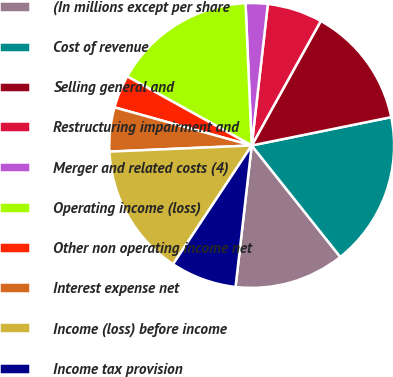Convert chart to OTSL. <chart><loc_0><loc_0><loc_500><loc_500><pie_chart><fcel>(In millions except per share<fcel>Cost of revenue<fcel>Selling general and<fcel>Restructuring impairment and<fcel>Merger and related costs (4)<fcel>Operating income (loss)<fcel>Other non operating income net<fcel>Interest expense net<fcel>Income (loss) before income<fcel>Income tax provision<nl><fcel>12.5%<fcel>17.5%<fcel>13.75%<fcel>6.25%<fcel>2.5%<fcel>16.25%<fcel>3.75%<fcel>5.0%<fcel>15.0%<fcel>7.5%<nl></chart> 